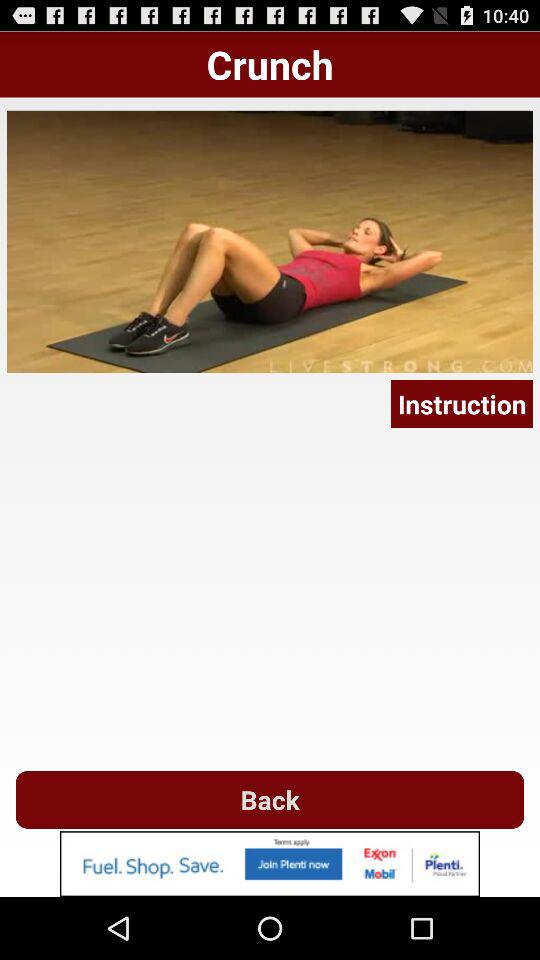What exercise name is displayed? The displayed exercise name is the crunch. 